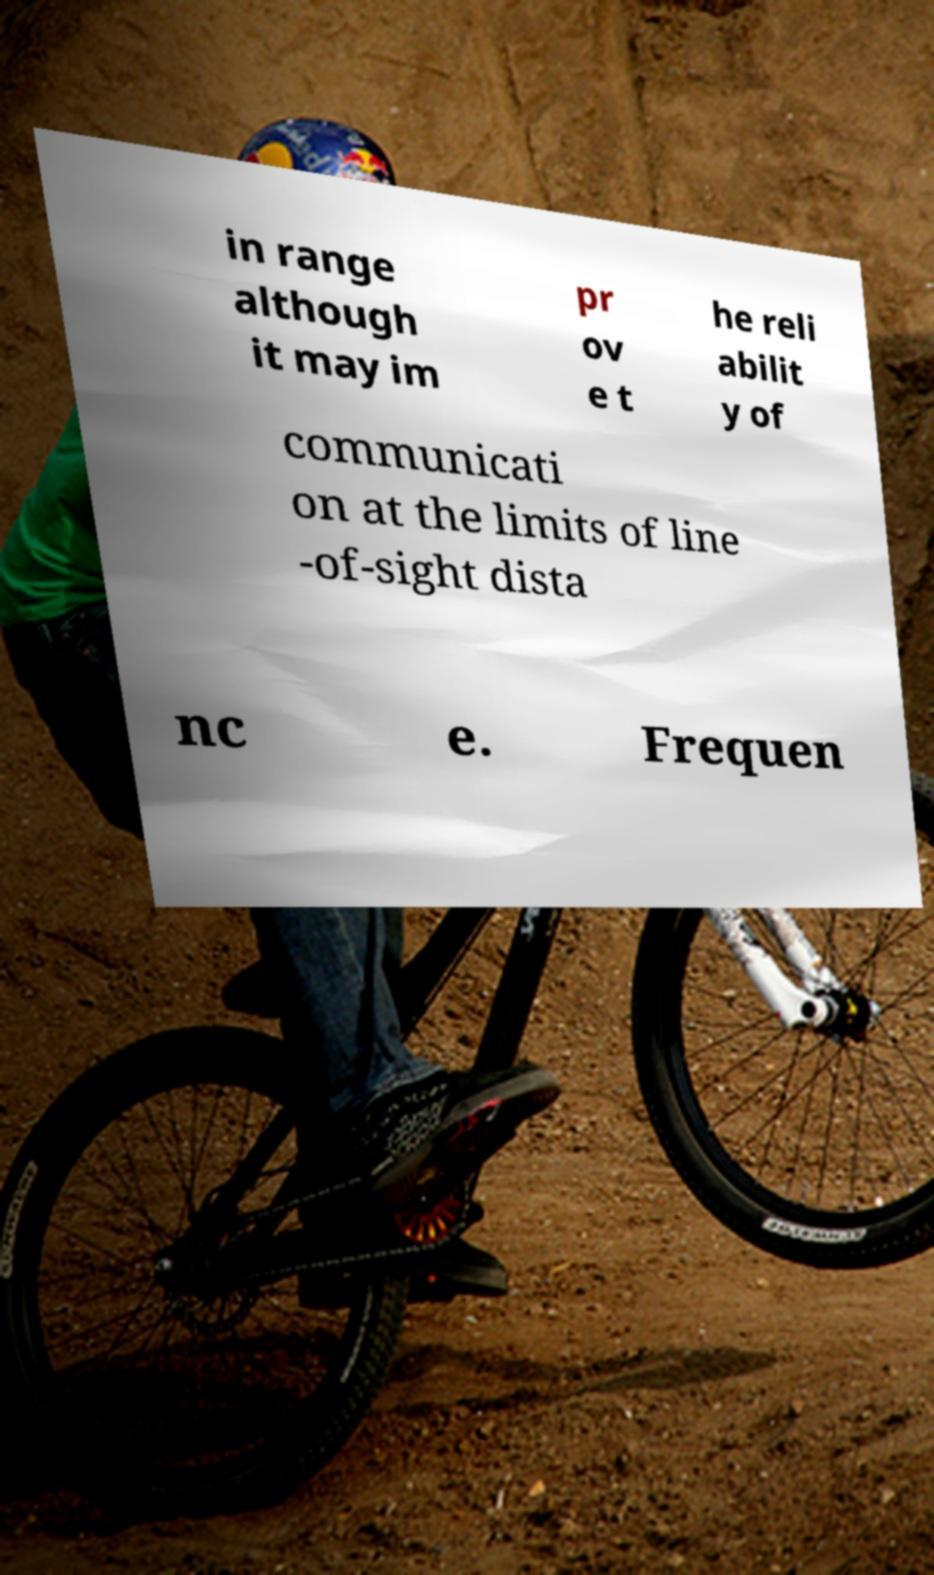Could you assist in decoding the text presented in this image and type it out clearly? in range although it may im pr ov e t he reli abilit y of communicati on at the limits of line -of-sight dista nc e. Frequen 